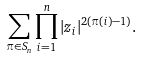Convert formula to latex. <formula><loc_0><loc_0><loc_500><loc_500>\sum _ { \pi \in S _ { n } } \prod _ { i = 1 } ^ { n } | z _ { i } | ^ { 2 ( \pi ( i ) - 1 ) } .</formula> 